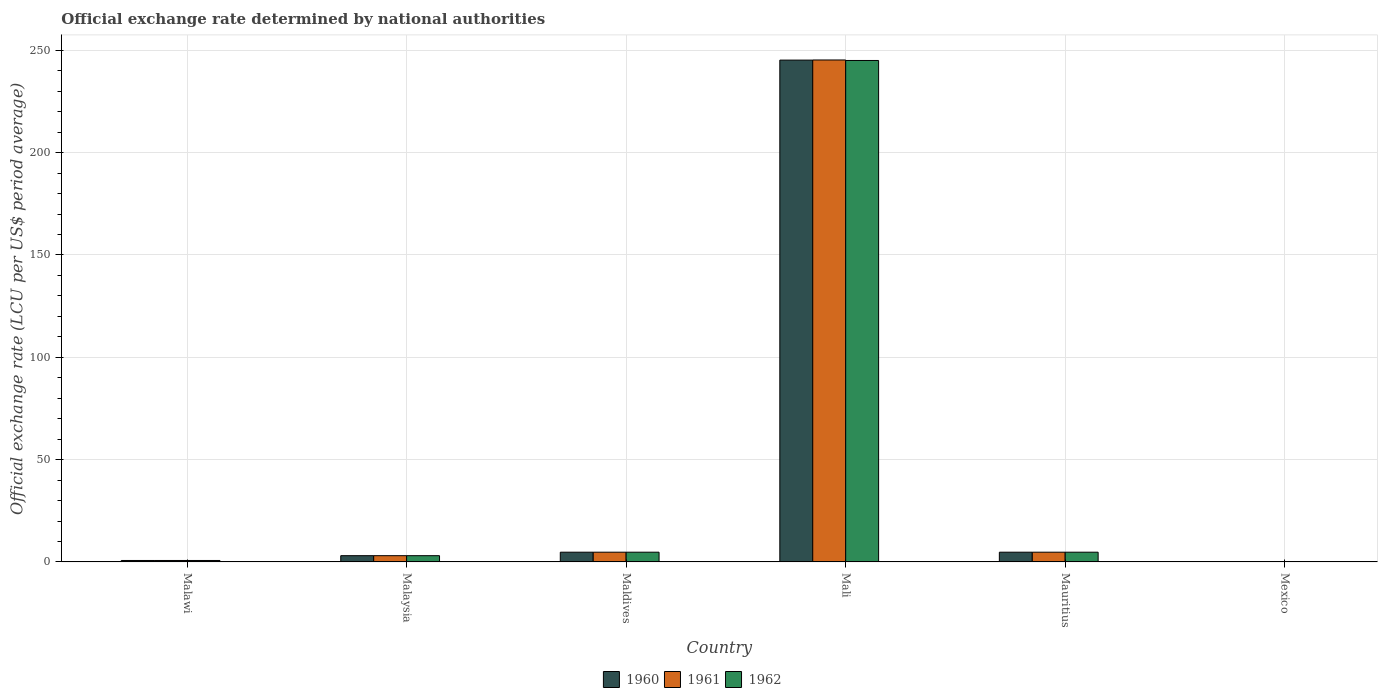How many different coloured bars are there?
Offer a very short reply. 3. Are the number of bars per tick equal to the number of legend labels?
Ensure brevity in your answer.  Yes. How many bars are there on the 4th tick from the right?
Your answer should be compact. 3. What is the label of the 3rd group of bars from the left?
Ensure brevity in your answer.  Maldives. In how many cases, is the number of bars for a given country not equal to the number of legend labels?
Your answer should be compact. 0. What is the official exchange rate in 1962 in Maldives?
Give a very brief answer. 4.76. Across all countries, what is the maximum official exchange rate in 1960?
Your answer should be compact. 245.2. Across all countries, what is the minimum official exchange rate in 1962?
Provide a succinct answer. 0.01. In which country was the official exchange rate in 1961 maximum?
Ensure brevity in your answer.  Mali. In which country was the official exchange rate in 1961 minimum?
Ensure brevity in your answer.  Mexico. What is the total official exchange rate in 1962 in the graph?
Your answer should be compact. 258.33. What is the difference between the official exchange rate in 1961 in Malawi and that in Mauritius?
Your answer should be very brief. -4.05. What is the difference between the official exchange rate in 1960 in Maldives and the official exchange rate in 1962 in Malaysia?
Your response must be concise. 1.7. What is the average official exchange rate in 1961 per country?
Make the answer very short. 43.1. What is the difference between the official exchange rate of/in 1962 and official exchange rate of/in 1961 in Mauritius?
Give a very brief answer. 0. What is the ratio of the official exchange rate in 1962 in Malaysia to that in Mali?
Offer a terse response. 0.01. Is the difference between the official exchange rate in 1962 in Maldives and Mexico greater than the difference between the official exchange rate in 1961 in Maldives and Mexico?
Offer a very short reply. No. What is the difference between the highest and the second highest official exchange rate in 1960?
Give a very brief answer. -240.43. What is the difference between the highest and the lowest official exchange rate in 1960?
Keep it short and to the point. 245.18. In how many countries, is the official exchange rate in 1961 greater than the average official exchange rate in 1961 taken over all countries?
Provide a succinct answer. 1. Is it the case that in every country, the sum of the official exchange rate in 1962 and official exchange rate in 1961 is greater than the official exchange rate in 1960?
Give a very brief answer. Yes. Are all the bars in the graph horizontal?
Your answer should be very brief. No. Are the values on the major ticks of Y-axis written in scientific E-notation?
Give a very brief answer. No. Where does the legend appear in the graph?
Your answer should be compact. Bottom center. How many legend labels are there?
Provide a short and direct response. 3. How are the legend labels stacked?
Your response must be concise. Horizontal. What is the title of the graph?
Keep it short and to the point. Official exchange rate determined by national authorities. Does "2004" appear as one of the legend labels in the graph?
Give a very brief answer. No. What is the label or title of the Y-axis?
Give a very brief answer. Official exchange rate (LCU per US$ period average). What is the Official exchange rate (LCU per US$ period average) in 1960 in Malawi?
Keep it short and to the point. 0.71. What is the Official exchange rate (LCU per US$ period average) of 1961 in Malawi?
Offer a very short reply. 0.71. What is the Official exchange rate (LCU per US$ period average) in 1962 in Malawi?
Ensure brevity in your answer.  0.71. What is the Official exchange rate (LCU per US$ period average) in 1960 in Malaysia?
Make the answer very short. 3.06. What is the Official exchange rate (LCU per US$ period average) in 1961 in Malaysia?
Make the answer very short. 3.06. What is the Official exchange rate (LCU per US$ period average) in 1962 in Malaysia?
Provide a short and direct response. 3.06. What is the Official exchange rate (LCU per US$ period average) in 1960 in Maldives?
Your answer should be very brief. 4.76. What is the Official exchange rate (LCU per US$ period average) in 1961 in Maldives?
Ensure brevity in your answer.  4.76. What is the Official exchange rate (LCU per US$ period average) in 1962 in Maldives?
Provide a succinct answer. 4.76. What is the Official exchange rate (LCU per US$ period average) of 1960 in Mali?
Your answer should be very brief. 245.2. What is the Official exchange rate (LCU per US$ period average) in 1961 in Mali?
Make the answer very short. 245.26. What is the Official exchange rate (LCU per US$ period average) in 1962 in Mali?
Your response must be concise. 245.01. What is the Official exchange rate (LCU per US$ period average) in 1960 in Mauritius?
Your answer should be compact. 4.76. What is the Official exchange rate (LCU per US$ period average) of 1961 in Mauritius?
Provide a succinct answer. 4.76. What is the Official exchange rate (LCU per US$ period average) in 1962 in Mauritius?
Give a very brief answer. 4.76. What is the Official exchange rate (LCU per US$ period average) in 1960 in Mexico?
Provide a short and direct response. 0.01. What is the Official exchange rate (LCU per US$ period average) of 1961 in Mexico?
Your answer should be compact. 0.01. What is the Official exchange rate (LCU per US$ period average) of 1962 in Mexico?
Your answer should be compact. 0.01. Across all countries, what is the maximum Official exchange rate (LCU per US$ period average) of 1960?
Give a very brief answer. 245.2. Across all countries, what is the maximum Official exchange rate (LCU per US$ period average) of 1961?
Provide a short and direct response. 245.26. Across all countries, what is the maximum Official exchange rate (LCU per US$ period average) in 1962?
Make the answer very short. 245.01. Across all countries, what is the minimum Official exchange rate (LCU per US$ period average) in 1960?
Make the answer very short. 0.01. Across all countries, what is the minimum Official exchange rate (LCU per US$ period average) in 1961?
Your answer should be compact. 0.01. Across all countries, what is the minimum Official exchange rate (LCU per US$ period average) in 1962?
Keep it short and to the point. 0.01. What is the total Official exchange rate (LCU per US$ period average) of 1960 in the graph?
Make the answer very short. 258.51. What is the total Official exchange rate (LCU per US$ period average) in 1961 in the graph?
Provide a succinct answer. 258.57. What is the total Official exchange rate (LCU per US$ period average) of 1962 in the graph?
Provide a short and direct response. 258.33. What is the difference between the Official exchange rate (LCU per US$ period average) in 1960 in Malawi and that in Malaysia?
Provide a short and direct response. -2.35. What is the difference between the Official exchange rate (LCU per US$ period average) of 1961 in Malawi and that in Malaysia?
Give a very brief answer. -2.35. What is the difference between the Official exchange rate (LCU per US$ period average) of 1962 in Malawi and that in Malaysia?
Provide a succinct answer. -2.35. What is the difference between the Official exchange rate (LCU per US$ period average) of 1960 in Malawi and that in Maldives?
Offer a terse response. -4.05. What is the difference between the Official exchange rate (LCU per US$ period average) of 1961 in Malawi and that in Maldives?
Your response must be concise. -4.05. What is the difference between the Official exchange rate (LCU per US$ period average) of 1962 in Malawi and that in Maldives?
Provide a succinct answer. -4.05. What is the difference between the Official exchange rate (LCU per US$ period average) of 1960 in Malawi and that in Mali?
Provide a short and direct response. -244.48. What is the difference between the Official exchange rate (LCU per US$ period average) in 1961 in Malawi and that in Mali?
Your answer should be compact. -244.55. What is the difference between the Official exchange rate (LCU per US$ period average) in 1962 in Malawi and that in Mali?
Provide a succinct answer. -244.3. What is the difference between the Official exchange rate (LCU per US$ period average) in 1960 in Malawi and that in Mauritius?
Your response must be concise. -4.05. What is the difference between the Official exchange rate (LCU per US$ period average) of 1961 in Malawi and that in Mauritius?
Provide a short and direct response. -4.05. What is the difference between the Official exchange rate (LCU per US$ period average) of 1962 in Malawi and that in Mauritius?
Provide a succinct answer. -4.05. What is the difference between the Official exchange rate (LCU per US$ period average) in 1960 in Malawi and that in Mexico?
Provide a succinct answer. 0.7. What is the difference between the Official exchange rate (LCU per US$ period average) of 1961 in Malawi and that in Mexico?
Your answer should be compact. 0.7. What is the difference between the Official exchange rate (LCU per US$ period average) of 1962 in Malawi and that in Mexico?
Offer a terse response. 0.7. What is the difference between the Official exchange rate (LCU per US$ period average) of 1960 in Malaysia and that in Maldives?
Offer a very short reply. -1.7. What is the difference between the Official exchange rate (LCU per US$ period average) in 1961 in Malaysia and that in Maldives?
Your answer should be very brief. -1.7. What is the difference between the Official exchange rate (LCU per US$ period average) in 1962 in Malaysia and that in Maldives?
Offer a terse response. -1.7. What is the difference between the Official exchange rate (LCU per US$ period average) of 1960 in Malaysia and that in Mali?
Make the answer very short. -242.13. What is the difference between the Official exchange rate (LCU per US$ period average) of 1961 in Malaysia and that in Mali?
Keep it short and to the point. -242.2. What is the difference between the Official exchange rate (LCU per US$ period average) of 1962 in Malaysia and that in Mali?
Offer a very short reply. -241.95. What is the difference between the Official exchange rate (LCU per US$ period average) in 1960 in Malaysia and that in Mauritius?
Keep it short and to the point. -1.7. What is the difference between the Official exchange rate (LCU per US$ period average) of 1961 in Malaysia and that in Mauritius?
Make the answer very short. -1.7. What is the difference between the Official exchange rate (LCU per US$ period average) of 1962 in Malaysia and that in Mauritius?
Offer a very short reply. -1.7. What is the difference between the Official exchange rate (LCU per US$ period average) of 1960 in Malaysia and that in Mexico?
Keep it short and to the point. 3.05. What is the difference between the Official exchange rate (LCU per US$ period average) in 1961 in Malaysia and that in Mexico?
Offer a very short reply. 3.05. What is the difference between the Official exchange rate (LCU per US$ period average) of 1962 in Malaysia and that in Mexico?
Provide a short and direct response. 3.05. What is the difference between the Official exchange rate (LCU per US$ period average) in 1960 in Maldives and that in Mali?
Keep it short and to the point. -240.43. What is the difference between the Official exchange rate (LCU per US$ period average) of 1961 in Maldives and that in Mali?
Keep it short and to the point. -240.5. What is the difference between the Official exchange rate (LCU per US$ period average) in 1962 in Maldives and that in Mali?
Provide a succinct answer. -240.25. What is the difference between the Official exchange rate (LCU per US$ period average) of 1960 in Maldives and that in Mauritius?
Offer a terse response. 0. What is the difference between the Official exchange rate (LCU per US$ period average) in 1961 in Maldives and that in Mauritius?
Make the answer very short. 0. What is the difference between the Official exchange rate (LCU per US$ period average) in 1962 in Maldives and that in Mauritius?
Offer a very short reply. 0. What is the difference between the Official exchange rate (LCU per US$ period average) of 1960 in Maldives and that in Mexico?
Ensure brevity in your answer.  4.75. What is the difference between the Official exchange rate (LCU per US$ period average) of 1961 in Maldives and that in Mexico?
Offer a very short reply. 4.75. What is the difference between the Official exchange rate (LCU per US$ period average) in 1962 in Maldives and that in Mexico?
Provide a short and direct response. 4.75. What is the difference between the Official exchange rate (LCU per US$ period average) of 1960 in Mali and that in Mauritius?
Provide a succinct answer. 240.43. What is the difference between the Official exchange rate (LCU per US$ period average) of 1961 in Mali and that in Mauritius?
Offer a very short reply. 240.5. What is the difference between the Official exchange rate (LCU per US$ period average) of 1962 in Mali and that in Mauritius?
Offer a very short reply. 240.25. What is the difference between the Official exchange rate (LCU per US$ period average) of 1960 in Mali and that in Mexico?
Give a very brief answer. 245.18. What is the difference between the Official exchange rate (LCU per US$ period average) in 1961 in Mali and that in Mexico?
Ensure brevity in your answer.  245.25. What is the difference between the Official exchange rate (LCU per US$ period average) of 1962 in Mali and that in Mexico?
Your answer should be compact. 245. What is the difference between the Official exchange rate (LCU per US$ period average) in 1960 in Mauritius and that in Mexico?
Ensure brevity in your answer.  4.75. What is the difference between the Official exchange rate (LCU per US$ period average) in 1961 in Mauritius and that in Mexico?
Keep it short and to the point. 4.75. What is the difference between the Official exchange rate (LCU per US$ period average) in 1962 in Mauritius and that in Mexico?
Provide a succinct answer. 4.75. What is the difference between the Official exchange rate (LCU per US$ period average) of 1960 in Malawi and the Official exchange rate (LCU per US$ period average) of 1961 in Malaysia?
Make the answer very short. -2.35. What is the difference between the Official exchange rate (LCU per US$ period average) of 1960 in Malawi and the Official exchange rate (LCU per US$ period average) of 1962 in Malaysia?
Offer a very short reply. -2.35. What is the difference between the Official exchange rate (LCU per US$ period average) in 1961 in Malawi and the Official exchange rate (LCU per US$ period average) in 1962 in Malaysia?
Your answer should be very brief. -2.35. What is the difference between the Official exchange rate (LCU per US$ period average) of 1960 in Malawi and the Official exchange rate (LCU per US$ period average) of 1961 in Maldives?
Provide a short and direct response. -4.05. What is the difference between the Official exchange rate (LCU per US$ period average) of 1960 in Malawi and the Official exchange rate (LCU per US$ period average) of 1962 in Maldives?
Your answer should be compact. -4.05. What is the difference between the Official exchange rate (LCU per US$ period average) in 1961 in Malawi and the Official exchange rate (LCU per US$ period average) in 1962 in Maldives?
Offer a very short reply. -4.05. What is the difference between the Official exchange rate (LCU per US$ period average) of 1960 in Malawi and the Official exchange rate (LCU per US$ period average) of 1961 in Mali?
Ensure brevity in your answer.  -244.55. What is the difference between the Official exchange rate (LCU per US$ period average) of 1960 in Malawi and the Official exchange rate (LCU per US$ period average) of 1962 in Mali?
Provide a short and direct response. -244.3. What is the difference between the Official exchange rate (LCU per US$ period average) in 1961 in Malawi and the Official exchange rate (LCU per US$ period average) in 1962 in Mali?
Offer a very short reply. -244.3. What is the difference between the Official exchange rate (LCU per US$ period average) in 1960 in Malawi and the Official exchange rate (LCU per US$ period average) in 1961 in Mauritius?
Keep it short and to the point. -4.05. What is the difference between the Official exchange rate (LCU per US$ period average) in 1960 in Malawi and the Official exchange rate (LCU per US$ period average) in 1962 in Mauritius?
Your response must be concise. -4.05. What is the difference between the Official exchange rate (LCU per US$ period average) of 1961 in Malawi and the Official exchange rate (LCU per US$ period average) of 1962 in Mauritius?
Your answer should be compact. -4.05. What is the difference between the Official exchange rate (LCU per US$ period average) in 1960 in Malawi and the Official exchange rate (LCU per US$ period average) in 1961 in Mexico?
Give a very brief answer. 0.7. What is the difference between the Official exchange rate (LCU per US$ period average) of 1960 in Malawi and the Official exchange rate (LCU per US$ period average) of 1962 in Mexico?
Ensure brevity in your answer.  0.7. What is the difference between the Official exchange rate (LCU per US$ period average) in 1961 in Malawi and the Official exchange rate (LCU per US$ period average) in 1962 in Mexico?
Offer a very short reply. 0.7. What is the difference between the Official exchange rate (LCU per US$ period average) of 1960 in Malaysia and the Official exchange rate (LCU per US$ period average) of 1961 in Maldives?
Your answer should be very brief. -1.7. What is the difference between the Official exchange rate (LCU per US$ period average) in 1960 in Malaysia and the Official exchange rate (LCU per US$ period average) in 1962 in Maldives?
Your answer should be very brief. -1.7. What is the difference between the Official exchange rate (LCU per US$ period average) of 1961 in Malaysia and the Official exchange rate (LCU per US$ period average) of 1962 in Maldives?
Your response must be concise. -1.7. What is the difference between the Official exchange rate (LCU per US$ period average) of 1960 in Malaysia and the Official exchange rate (LCU per US$ period average) of 1961 in Mali?
Offer a terse response. -242.2. What is the difference between the Official exchange rate (LCU per US$ period average) of 1960 in Malaysia and the Official exchange rate (LCU per US$ period average) of 1962 in Mali?
Provide a short and direct response. -241.95. What is the difference between the Official exchange rate (LCU per US$ period average) of 1961 in Malaysia and the Official exchange rate (LCU per US$ period average) of 1962 in Mali?
Make the answer very short. -241.95. What is the difference between the Official exchange rate (LCU per US$ period average) of 1960 in Malaysia and the Official exchange rate (LCU per US$ period average) of 1961 in Mauritius?
Ensure brevity in your answer.  -1.7. What is the difference between the Official exchange rate (LCU per US$ period average) of 1960 in Malaysia and the Official exchange rate (LCU per US$ period average) of 1962 in Mauritius?
Offer a terse response. -1.7. What is the difference between the Official exchange rate (LCU per US$ period average) of 1961 in Malaysia and the Official exchange rate (LCU per US$ period average) of 1962 in Mauritius?
Your answer should be compact. -1.7. What is the difference between the Official exchange rate (LCU per US$ period average) of 1960 in Malaysia and the Official exchange rate (LCU per US$ period average) of 1961 in Mexico?
Provide a short and direct response. 3.05. What is the difference between the Official exchange rate (LCU per US$ period average) of 1960 in Malaysia and the Official exchange rate (LCU per US$ period average) of 1962 in Mexico?
Provide a succinct answer. 3.05. What is the difference between the Official exchange rate (LCU per US$ period average) of 1961 in Malaysia and the Official exchange rate (LCU per US$ period average) of 1962 in Mexico?
Keep it short and to the point. 3.05. What is the difference between the Official exchange rate (LCU per US$ period average) of 1960 in Maldives and the Official exchange rate (LCU per US$ period average) of 1961 in Mali?
Offer a very short reply. -240.5. What is the difference between the Official exchange rate (LCU per US$ period average) in 1960 in Maldives and the Official exchange rate (LCU per US$ period average) in 1962 in Mali?
Keep it short and to the point. -240.25. What is the difference between the Official exchange rate (LCU per US$ period average) in 1961 in Maldives and the Official exchange rate (LCU per US$ period average) in 1962 in Mali?
Make the answer very short. -240.25. What is the difference between the Official exchange rate (LCU per US$ period average) in 1960 in Maldives and the Official exchange rate (LCU per US$ period average) in 1962 in Mauritius?
Provide a short and direct response. 0. What is the difference between the Official exchange rate (LCU per US$ period average) in 1960 in Maldives and the Official exchange rate (LCU per US$ period average) in 1961 in Mexico?
Offer a very short reply. 4.75. What is the difference between the Official exchange rate (LCU per US$ period average) in 1960 in Maldives and the Official exchange rate (LCU per US$ period average) in 1962 in Mexico?
Offer a terse response. 4.75. What is the difference between the Official exchange rate (LCU per US$ period average) of 1961 in Maldives and the Official exchange rate (LCU per US$ period average) of 1962 in Mexico?
Ensure brevity in your answer.  4.75. What is the difference between the Official exchange rate (LCU per US$ period average) of 1960 in Mali and the Official exchange rate (LCU per US$ period average) of 1961 in Mauritius?
Offer a very short reply. 240.43. What is the difference between the Official exchange rate (LCU per US$ period average) in 1960 in Mali and the Official exchange rate (LCU per US$ period average) in 1962 in Mauritius?
Provide a short and direct response. 240.43. What is the difference between the Official exchange rate (LCU per US$ period average) of 1961 in Mali and the Official exchange rate (LCU per US$ period average) of 1962 in Mauritius?
Give a very brief answer. 240.5. What is the difference between the Official exchange rate (LCU per US$ period average) of 1960 in Mali and the Official exchange rate (LCU per US$ period average) of 1961 in Mexico?
Offer a terse response. 245.18. What is the difference between the Official exchange rate (LCU per US$ period average) in 1960 in Mali and the Official exchange rate (LCU per US$ period average) in 1962 in Mexico?
Provide a short and direct response. 245.18. What is the difference between the Official exchange rate (LCU per US$ period average) in 1961 in Mali and the Official exchange rate (LCU per US$ period average) in 1962 in Mexico?
Offer a terse response. 245.25. What is the difference between the Official exchange rate (LCU per US$ period average) of 1960 in Mauritius and the Official exchange rate (LCU per US$ period average) of 1961 in Mexico?
Provide a short and direct response. 4.75. What is the difference between the Official exchange rate (LCU per US$ period average) in 1960 in Mauritius and the Official exchange rate (LCU per US$ period average) in 1962 in Mexico?
Your response must be concise. 4.75. What is the difference between the Official exchange rate (LCU per US$ period average) in 1961 in Mauritius and the Official exchange rate (LCU per US$ period average) in 1962 in Mexico?
Make the answer very short. 4.75. What is the average Official exchange rate (LCU per US$ period average) of 1960 per country?
Offer a very short reply. 43.08. What is the average Official exchange rate (LCU per US$ period average) in 1961 per country?
Offer a very short reply. 43.1. What is the average Official exchange rate (LCU per US$ period average) in 1962 per country?
Provide a short and direct response. 43.05. What is the difference between the Official exchange rate (LCU per US$ period average) in 1960 and Official exchange rate (LCU per US$ period average) in 1961 in Maldives?
Offer a very short reply. 0. What is the difference between the Official exchange rate (LCU per US$ period average) of 1960 and Official exchange rate (LCU per US$ period average) of 1962 in Maldives?
Offer a very short reply. 0. What is the difference between the Official exchange rate (LCU per US$ period average) of 1961 and Official exchange rate (LCU per US$ period average) of 1962 in Maldives?
Make the answer very short. 0. What is the difference between the Official exchange rate (LCU per US$ period average) of 1960 and Official exchange rate (LCU per US$ period average) of 1961 in Mali?
Offer a terse response. -0.07. What is the difference between the Official exchange rate (LCU per US$ period average) in 1960 and Official exchange rate (LCU per US$ period average) in 1962 in Mali?
Your response must be concise. 0.18. What is the difference between the Official exchange rate (LCU per US$ period average) in 1961 and Official exchange rate (LCU per US$ period average) in 1962 in Mali?
Your answer should be compact. 0.25. What is the difference between the Official exchange rate (LCU per US$ period average) of 1961 and Official exchange rate (LCU per US$ period average) of 1962 in Mauritius?
Make the answer very short. 0. What is the difference between the Official exchange rate (LCU per US$ period average) of 1960 and Official exchange rate (LCU per US$ period average) of 1961 in Mexico?
Make the answer very short. 0. What is the difference between the Official exchange rate (LCU per US$ period average) of 1960 and Official exchange rate (LCU per US$ period average) of 1962 in Mexico?
Offer a very short reply. 0. What is the difference between the Official exchange rate (LCU per US$ period average) of 1961 and Official exchange rate (LCU per US$ period average) of 1962 in Mexico?
Ensure brevity in your answer.  0. What is the ratio of the Official exchange rate (LCU per US$ period average) in 1960 in Malawi to that in Malaysia?
Offer a very short reply. 0.23. What is the ratio of the Official exchange rate (LCU per US$ period average) of 1961 in Malawi to that in Malaysia?
Provide a short and direct response. 0.23. What is the ratio of the Official exchange rate (LCU per US$ period average) in 1962 in Malawi to that in Malaysia?
Your answer should be very brief. 0.23. What is the ratio of the Official exchange rate (LCU per US$ period average) in 1960 in Malawi to that in Maldives?
Offer a very short reply. 0.15. What is the ratio of the Official exchange rate (LCU per US$ period average) in 1961 in Malawi to that in Maldives?
Make the answer very short. 0.15. What is the ratio of the Official exchange rate (LCU per US$ period average) of 1962 in Malawi to that in Maldives?
Ensure brevity in your answer.  0.15. What is the ratio of the Official exchange rate (LCU per US$ period average) in 1960 in Malawi to that in Mali?
Offer a very short reply. 0. What is the ratio of the Official exchange rate (LCU per US$ period average) of 1961 in Malawi to that in Mali?
Keep it short and to the point. 0. What is the ratio of the Official exchange rate (LCU per US$ period average) in 1962 in Malawi to that in Mali?
Your response must be concise. 0. What is the ratio of the Official exchange rate (LCU per US$ period average) in 1961 in Malawi to that in Mauritius?
Keep it short and to the point. 0.15. What is the ratio of the Official exchange rate (LCU per US$ period average) in 1962 in Malawi to that in Mauritius?
Provide a succinct answer. 0.15. What is the ratio of the Official exchange rate (LCU per US$ period average) in 1960 in Malawi to that in Mexico?
Make the answer very short. 57.14. What is the ratio of the Official exchange rate (LCU per US$ period average) in 1961 in Malawi to that in Mexico?
Give a very brief answer. 57.14. What is the ratio of the Official exchange rate (LCU per US$ period average) in 1962 in Malawi to that in Mexico?
Ensure brevity in your answer.  57.14. What is the ratio of the Official exchange rate (LCU per US$ period average) of 1960 in Malaysia to that in Maldives?
Your answer should be very brief. 0.64. What is the ratio of the Official exchange rate (LCU per US$ period average) in 1961 in Malaysia to that in Maldives?
Provide a succinct answer. 0.64. What is the ratio of the Official exchange rate (LCU per US$ period average) of 1962 in Malaysia to that in Maldives?
Give a very brief answer. 0.64. What is the ratio of the Official exchange rate (LCU per US$ period average) of 1960 in Malaysia to that in Mali?
Provide a short and direct response. 0.01. What is the ratio of the Official exchange rate (LCU per US$ period average) of 1961 in Malaysia to that in Mali?
Give a very brief answer. 0.01. What is the ratio of the Official exchange rate (LCU per US$ period average) of 1962 in Malaysia to that in Mali?
Give a very brief answer. 0.01. What is the ratio of the Official exchange rate (LCU per US$ period average) of 1960 in Malaysia to that in Mauritius?
Offer a terse response. 0.64. What is the ratio of the Official exchange rate (LCU per US$ period average) of 1961 in Malaysia to that in Mauritius?
Your answer should be compact. 0.64. What is the ratio of the Official exchange rate (LCU per US$ period average) of 1962 in Malaysia to that in Mauritius?
Offer a terse response. 0.64. What is the ratio of the Official exchange rate (LCU per US$ period average) of 1960 in Malaysia to that in Mexico?
Your response must be concise. 244.9. What is the ratio of the Official exchange rate (LCU per US$ period average) of 1961 in Malaysia to that in Mexico?
Offer a very short reply. 244.9. What is the ratio of the Official exchange rate (LCU per US$ period average) of 1962 in Malaysia to that in Mexico?
Your answer should be very brief. 244.9. What is the ratio of the Official exchange rate (LCU per US$ period average) of 1960 in Maldives to that in Mali?
Offer a very short reply. 0.02. What is the ratio of the Official exchange rate (LCU per US$ period average) in 1961 in Maldives to that in Mali?
Give a very brief answer. 0.02. What is the ratio of the Official exchange rate (LCU per US$ period average) in 1962 in Maldives to that in Mali?
Your answer should be very brief. 0.02. What is the ratio of the Official exchange rate (LCU per US$ period average) of 1960 in Maldives to that in Mexico?
Provide a short and direct response. 380.95. What is the ratio of the Official exchange rate (LCU per US$ period average) in 1961 in Maldives to that in Mexico?
Give a very brief answer. 380.95. What is the ratio of the Official exchange rate (LCU per US$ period average) in 1962 in Maldives to that in Mexico?
Keep it short and to the point. 380.95. What is the ratio of the Official exchange rate (LCU per US$ period average) of 1960 in Mali to that in Mauritius?
Provide a short and direct response. 51.49. What is the ratio of the Official exchange rate (LCU per US$ period average) in 1961 in Mali to that in Mauritius?
Provide a short and direct response. 51.5. What is the ratio of the Official exchange rate (LCU per US$ period average) of 1962 in Mali to that in Mauritius?
Your answer should be compact. 51.45. What is the ratio of the Official exchange rate (LCU per US$ period average) of 1960 in Mali to that in Mexico?
Make the answer very short. 1.96e+04. What is the ratio of the Official exchange rate (LCU per US$ period average) of 1961 in Mali to that in Mexico?
Offer a terse response. 1.96e+04. What is the ratio of the Official exchange rate (LCU per US$ period average) of 1962 in Mali to that in Mexico?
Give a very brief answer. 1.96e+04. What is the ratio of the Official exchange rate (LCU per US$ period average) of 1960 in Mauritius to that in Mexico?
Make the answer very short. 380.95. What is the ratio of the Official exchange rate (LCU per US$ period average) of 1961 in Mauritius to that in Mexico?
Provide a succinct answer. 380.95. What is the ratio of the Official exchange rate (LCU per US$ period average) in 1962 in Mauritius to that in Mexico?
Your answer should be very brief. 380.95. What is the difference between the highest and the second highest Official exchange rate (LCU per US$ period average) of 1960?
Offer a terse response. 240.43. What is the difference between the highest and the second highest Official exchange rate (LCU per US$ period average) in 1961?
Give a very brief answer. 240.5. What is the difference between the highest and the second highest Official exchange rate (LCU per US$ period average) in 1962?
Offer a terse response. 240.25. What is the difference between the highest and the lowest Official exchange rate (LCU per US$ period average) in 1960?
Make the answer very short. 245.18. What is the difference between the highest and the lowest Official exchange rate (LCU per US$ period average) in 1961?
Provide a succinct answer. 245.25. What is the difference between the highest and the lowest Official exchange rate (LCU per US$ period average) of 1962?
Your answer should be very brief. 245. 